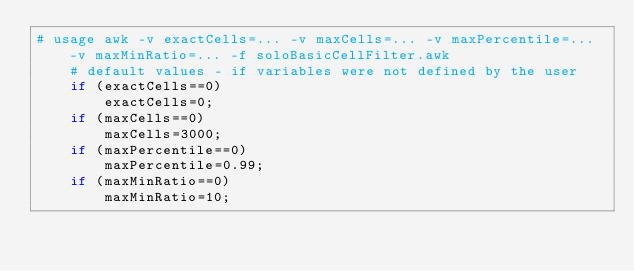<code> <loc_0><loc_0><loc_500><loc_500><_Awk_># usage awk -v exactCells=... -v maxCells=... -v maxPercentile=... -v maxMinRatio=... -f soloBasicCellFilter.awk 
    # default values - if variables were not defined by the user
    if (exactCells==0)
        exactCells=0;
    if (maxCells==0)
        maxCells=3000;
    if (maxPercentile==0)
        maxPercentile=0.99;
    if (maxMinRatio==0)
        maxMinRatio=10;
</code> 